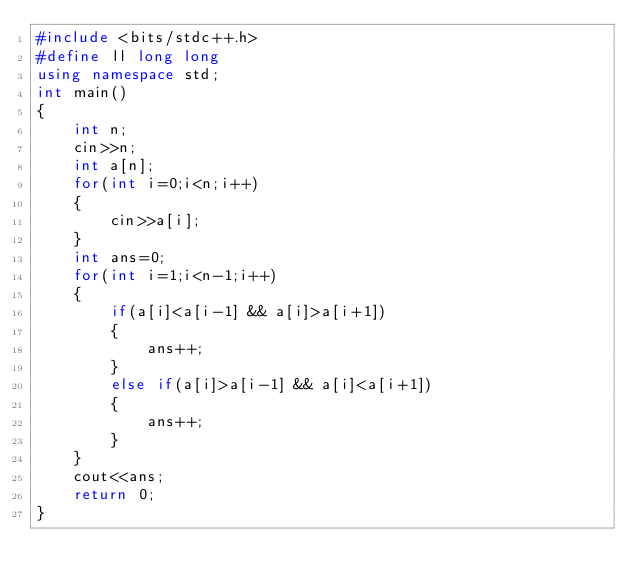Convert code to text. <code><loc_0><loc_0><loc_500><loc_500><_C++_>#include <bits/stdc++.h>
#define ll long long
using namespace std;
int main()
{
    int n;
    cin>>n;
    int a[n];
    for(int i=0;i<n;i++)
    {
        cin>>a[i];
    }
    int ans=0;
    for(int i=1;i<n-1;i++)
    {
        if(a[i]<a[i-1] && a[i]>a[i+1])
        {
            ans++;
        }
        else if(a[i]>a[i-1] && a[i]<a[i+1])
        {
            ans++;
        }
    }
    cout<<ans;
    return 0;
}








</code> 